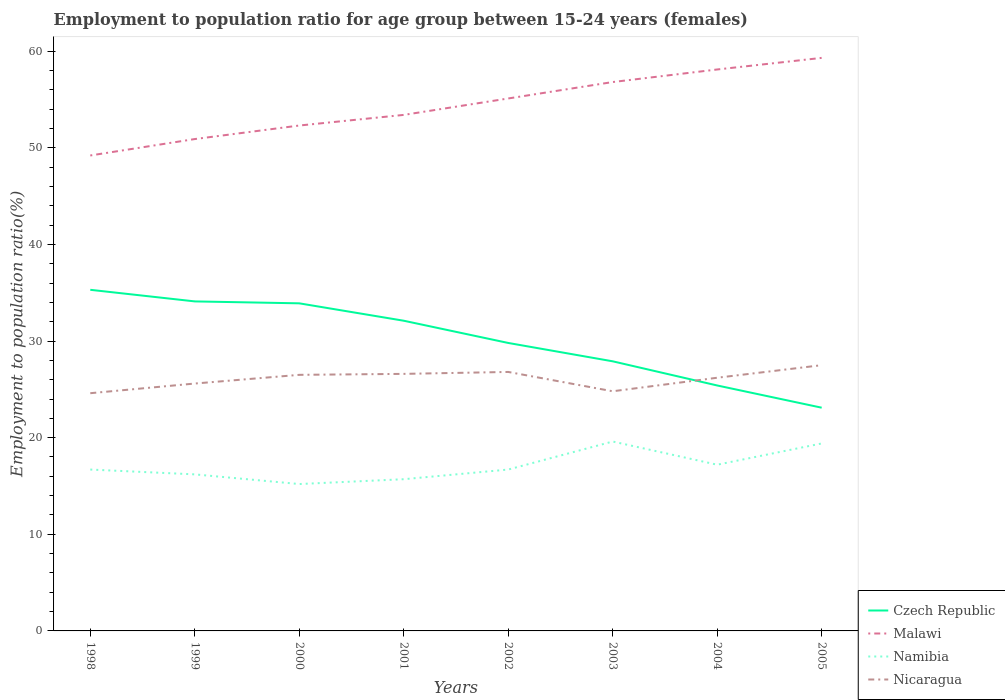How many different coloured lines are there?
Make the answer very short. 4. Does the line corresponding to Czech Republic intersect with the line corresponding to Nicaragua?
Offer a very short reply. Yes. Across all years, what is the maximum employment to population ratio in Nicaragua?
Offer a very short reply. 24.6. In which year was the employment to population ratio in Czech Republic maximum?
Your answer should be very brief. 2005. What is the total employment to population ratio in Malawi in the graph?
Provide a succinct answer. -8.4. What is the difference between the highest and the second highest employment to population ratio in Czech Republic?
Provide a succinct answer. 12.2. Are the values on the major ticks of Y-axis written in scientific E-notation?
Your answer should be compact. No. Does the graph contain grids?
Give a very brief answer. No. How are the legend labels stacked?
Provide a short and direct response. Vertical. What is the title of the graph?
Offer a terse response. Employment to population ratio for age group between 15-24 years (females). Does "Qatar" appear as one of the legend labels in the graph?
Keep it short and to the point. No. What is the label or title of the Y-axis?
Your response must be concise. Employment to population ratio(%). What is the Employment to population ratio(%) in Czech Republic in 1998?
Your response must be concise. 35.3. What is the Employment to population ratio(%) of Malawi in 1998?
Your answer should be compact. 49.2. What is the Employment to population ratio(%) in Namibia in 1998?
Offer a very short reply. 16.7. What is the Employment to population ratio(%) of Nicaragua in 1998?
Your answer should be compact. 24.6. What is the Employment to population ratio(%) of Czech Republic in 1999?
Your answer should be compact. 34.1. What is the Employment to population ratio(%) of Malawi in 1999?
Offer a very short reply. 50.9. What is the Employment to population ratio(%) of Namibia in 1999?
Your response must be concise. 16.2. What is the Employment to population ratio(%) of Nicaragua in 1999?
Your answer should be compact. 25.6. What is the Employment to population ratio(%) of Czech Republic in 2000?
Your response must be concise. 33.9. What is the Employment to population ratio(%) of Malawi in 2000?
Ensure brevity in your answer.  52.3. What is the Employment to population ratio(%) of Namibia in 2000?
Offer a very short reply. 15.2. What is the Employment to population ratio(%) in Nicaragua in 2000?
Ensure brevity in your answer.  26.5. What is the Employment to population ratio(%) of Czech Republic in 2001?
Offer a very short reply. 32.1. What is the Employment to population ratio(%) of Malawi in 2001?
Provide a succinct answer. 53.4. What is the Employment to population ratio(%) of Namibia in 2001?
Make the answer very short. 15.7. What is the Employment to population ratio(%) in Nicaragua in 2001?
Keep it short and to the point. 26.6. What is the Employment to population ratio(%) of Czech Republic in 2002?
Your response must be concise. 29.8. What is the Employment to population ratio(%) of Malawi in 2002?
Provide a succinct answer. 55.1. What is the Employment to population ratio(%) of Namibia in 2002?
Your answer should be very brief. 16.7. What is the Employment to population ratio(%) in Nicaragua in 2002?
Your answer should be very brief. 26.8. What is the Employment to population ratio(%) in Czech Republic in 2003?
Your answer should be compact. 27.9. What is the Employment to population ratio(%) of Malawi in 2003?
Make the answer very short. 56.8. What is the Employment to population ratio(%) of Namibia in 2003?
Your answer should be very brief. 19.6. What is the Employment to population ratio(%) in Nicaragua in 2003?
Ensure brevity in your answer.  24.8. What is the Employment to population ratio(%) in Czech Republic in 2004?
Offer a terse response. 25.4. What is the Employment to population ratio(%) in Malawi in 2004?
Your response must be concise. 58.1. What is the Employment to population ratio(%) in Namibia in 2004?
Ensure brevity in your answer.  17.2. What is the Employment to population ratio(%) in Nicaragua in 2004?
Provide a short and direct response. 26.2. What is the Employment to population ratio(%) of Czech Republic in 2005?
Offer a terse response. 23.1. What is the Employment to population ratio(%) in Malawi in 2005?
Offer a terse response. 59.3. What is the Employment to population ratio(%) of Namibia in 2005?
Keep it short and to the point. 19.4. Across all years, what is the maximum Employment to population ratio(%) in Czech Republic?
Ensure brevity in your answer.  35.3. Across all years, what is the maximum Employment to population ratio(%) of Malawi?
Provide a short and direct response. 59.3. Across all years, what is the maximum Employment to population ratio(%) in Namibia?
Provide a succinct answer. 19.6. Across all years, what is the maximum Employment to population ratio(%) of Nicaragua?
Provide a succinct answer. 27.5. Across all years, what is the minimum Employment to population ratio(%) of Czech Republic?
Your answer should be very brief. 23.1. Across all years, what is the minimum Employment to population ratio(%) in Malawi?
Your answer should be compact. 49.2. Across all years, what is the minimum Employment to population ratio(%) of Namibia?
Keep it short and to the point. 15.2. Across all years, what is the minimum Employment to population ratio(%) of Nicaragua?
Your response must be concise. 24.6. What is the total Employment to population ratio(%) in Czech Republic in the graph?
Keep it short and to the point. 241.6. What is the total Employment to population ratio(%) in Malawi in the graph?
Provide a succinct answer. 435.1. What is the total Employment to population ratio(%) in Namibia in the graph?
Your response must be concise. 136.7. What is the total Employment to population ratio(%) in Nicaragua in the graph?
Ensure brevity in your answer.  208.6. What is the difference between the Employment to population ratio(%) in Czech Republic in 1998 and that in 1999?
Keep it short and to the point. 1.2. What is the difference between the Employment to population ratio(%) in Malawi in 1998 and that in 1999?
Ensure brevity in your answer.  -1.7. What is the difference between the Employment to population ratio(%) of Malawi in 1998 and that in 2000?
Give a very brief answer. -3.1. What is the difference between the Employment to population ratio(%) in Namibia in 1998 and that in 2000?
Keep it short and to the point. 1.5. What is the difference between the Employment to population ratio(%) in Nicaragua in 1998 and that in 2000?
Your answer should be very brief. -1.9. What is the difference between the Employment to population ratio(%) in Malawi in 1998 and that in 2001?
Keep it short and to the point. -4.2. What is the difference between the Employment to population ratio(%) of Namibia in 1998 and that in 2001?
Ensure brevity in your answer.  1. What is the difference between the Employment to population ratio(%) in Czech Republic in 1998 and that in 2002?
Your answer should be compact. 5.5. What is the difference between the Employment to population ratio(%) in Namibia in 1998 and that in 2002?
Your answer should be very brief. 0. What is the difference between the Employment to population ratio(%) in Nicaragua in 1998 and that in 2002?
Ensure brevity in your answer.  -2.2. What is the difference between the Employment to population ratio(%) in Malawi in 1998 and that in 2003?
Your response must be concise. -7.6. What is the difference between the Employment to population ratio(%) of Namibia in 1998 and that in 2003?
Your response must be concise. -2.9. What is the difference between the Employment to population ratio(%) in Czech Republic in 1998 and that in 2004?
Make the answer very short. 9.9. What is the difference between the Employment to population ratio(%) in Malawi in 1998 and that in 2004?
Your answer should be compact. -8.9. What is the difference between the Employment to population ratio(%) of Namibia in 1998 and that in 2004?
Ensure brevity in your answer.  -0.5. What is the difference between the Employment to population ratio(%) in Namibia in 1998 and that in 2005?
Make the answer very short. -2.7. What is the difference between the Employment to population ratio(%) in Czech Republic in 1999 and that in 2000?
Provide a short and direct response. 0.2. What is the difference between the Employment to population ratio(%) of Namibia in 1999 and that in 2000?
Offer a terse response. 1. What is the difference between the Employment to population ratio(%) of Malawi in 1999 and that in 2001?
Make the answer very short. -2.5. What is the difference between the Employment to population ratio(%) in Namibia in 1999 and that in 2001?
Your answer should be very brief. 0.5. What is the difference between the Employment to population ratio(%) in Malawi in 1999 and that in 2002?
Your response must be concise. -4.2. What is the difference between the Employment to population ratio(%) of Namibia in 1999 and that in 2002?
Provide a succinct answer. -0.5. What is the difference between the Employment to population ratio(%) in Nicaragua in 1999 and that in 2002?
Ensure brevity in your answer.  -1.2. What is the difference between the Employment to population ratio(%) in Namibia in 1999 and that in 2003?
Ensure brevity in your answer.  -3.4. What is the difference between the Employment to population ratio(%) in Nicaragua in 1999 and that in 2003?
Provide a succinct answer. 0.8. What is the difference between the Employment to population ratio(%) in Malawi in 1999 and that in 2004?
Your response must be concise. -7.2. What is the difference between the Employment to population ratio(%) of Namibia in 1999 and that in 2004?
Provide a short and direct response. -1. What is the difference between the Employment to population ratio(%) of Nicaragua in 1999 and that in 2004?
Your response must be concise. -0.6. What is the difference between the Employment to population ratio(%) in Czech Republic in 1999 and that in 2005?
Offer a very short reply. 11. What is the difference between the Employment to population ratio(%) in Malawi in 1999 and that in 2005?
Ensure brevity in your answer.  -8.4. What is the difference between the Employment to population ratio(%) of Czech Republic in 2000 and that in 2001?
Ensure brevity in your answer.  1.8. What is the difference between the Employment to population ratio(%) in Nicaragua in 2000 and that in 2001?
Provide a succinct answer. -0.1. What is the difference between the Employment to population ratio(%) of Malawi in 2000 and that in 2002?
Provide a short and direct response. -2.8. What is the difference between the Employment to population ratio(%) of Nicaragua in 2000 and that in 2002?
Your answer should be compact. -0.3. What is the difference between the Employment to population ratio(%) in Namibia in 2000 and that in 2003?
Keep it short and to the point. -4.4. What is the difference between the Employment to population ratio(%) in Czech Republic in 2000 and that in 2004?
Ensure brevity in your answer.  8.5. What is the difference between the Employment to population ratio(%) in Namibia in 2000 and that in 2004?
Provide a short and direct response. -2. What is the difference between the Employment to population ratio(%) of Czech Republic in 2000 and that in 2005?
Keep it short and to the point. 10.8. What is the difference between the Employment to population ratio(%) of Malawi in 2000 and that in 2005?
Offer a terse response. -7. What is the difference between the Employment to population ratio(%) in Namibia in 2000 and that in 2005?
Your answer should be compact. -4.2. What is the difference between the Employment to population ratio(%) of Nicaragua in 2000 and that in 2005?
Make the answer very short. -1. What is the difference between the Employment to population ratio(%) of Namibia in 2001 and that in 2002?
Offer a terse response. -1. What is the difference between the Employment to population ratio(%) of Czech Republic in 2001 and that in 2003?
Provide a succinct answer. 4.2. What is the difference between the Employment to population ratio(%) in Malawi in 2001 and that in 2003?
Keep it short and to the point. -3.4. What is the difference between the Employment to population ratio(%) in Nicaragua in 2001 and that in 2003?
Your answer should be compact. 1.8. What is the difference between the Employment to population ratio(%) of Nicaragua in 2001 and that in 2004?
Offer a very short reply. 0.4. What is the difference between the Employment to population ratio(%) of Malawi in 2001 and that in 2005?
Your answer should be very brief. -5.9. What is the difference between the Employment to population ratio(%) in Nicaragua in 2001 and that in 2005?
Give a very brief answer. -0.9. What is the difference between the Employment to population ratio(%) of Malawi in 2002 and that in 2003?
Give a very brief answer. -1.7. What is the difference between the Employment to population ratio(%) in Namibia in 2002 and that in 2003?
Your answer should be compact. -2.9. What is the difference between the Employment to population ratio(%) of Nicaragua in 2002 and that in 2003?
Offer a very short reply. 2. What is the difference between the Employment to population ratio(%) of Czech Republic in 2002 and that in 2004?
Offer a very short reply. 4.4. What is the difference between the Employment to population ratio(%) of Malawi in 2002 and that in 2004?
Keep it short and to the point. -3. What is the difference between the Employment to population ratio(%) of Nicaragua in 2002 and that in 2004?
Your answer should be compact. 0.6. What is the difference between the Employment to population ratio(%) in Czech Republic in 2002 and that in 2005?
Give a very brief answer. 6.7. What is the difference between the Employment to population ratio(%) in Malawi in 2002 and that in 2005?
Your response must be concise. -4.2. What is the difference between the Employment to population ratio(%) of Namibia in 2002 and that in 2005?
Offer a terse response. -2.7. What is the difference between the Employment to population ratio(%) in Czech Republic in 2003 and that in 2004?
Your answer should be compact. 2.5. What is the difference between the Employment to population ratio(%) of Malawi in 2003 and that in 2004?
Offer a very short reply. -1.3. What is the difference between the Employment to population ratio(%) of Nicaragua in 2003 and that in 2004?
Ensure brevity in your answer.  -1.4. What is the difference between the Employment to population ratio(%) of Czech Republic in 2003 and that in 2005?
Provide a succinct answer. 4.8. What is the difference between the Employment to population ratio(%) of Malawi in 2003 and that in 2005?
Keep it short and to the point. -2.5. What is the difference between the Employment to population ratio(%) of Czech Republic in 2004 and that in 2005?
Make the answer very short. 2.3. What is the difference between the Employment to population ratio(%) of Malawi in 2004 and that in 2005?
Make the answer very short. -1.2. What is the difference between the Employment to population ratio(%) of Namibia in 2004 and that in 2005?
Give a very brief answer. -2.2. What is the difference between the Employment to population ratio(%) of Czech Republic in 1998 and the Employment to population ratio(%) of Malawi in 1999?
Your answer should be compact. -15.6. What is the difference between the Employment to population ratio(%) in Malawi in 1998 and the Employment to population ratio(%) in Nicaragua in 1999?
Make the answer very short. 23.6. What is the difference between the Employment to population ratio(%) of Namibia in 1998 and the Employment to population ratio(%) of Nicaragua in 1999?
Your response must be concise. -8.9. What is the difference between the Employment to population ratio(%) in Czech Republic in 1998 and the Employment to population ratio(%) in Malawi in 2000?
Make the answer very short. -17. What is the difference between the Employment to population ratio(%) of Czech Republic in 1998 and the Employment to population ratio(%) of Namibia in 2000?
Keep it short and to the point. 20.1. What is the difference between the Employment to population ratio(%) of Malawi in 1998 and the Employment to population ratio(%) of Nicaragua in 2000?
Your response must be concise. 22.7. What is the difference between the Employment to population ratio(%) of Namibia in 1998 and the Employment to population ratio(%) of Nicaragua in 2000?
Give a very brief answer. -9.8. What is the difference between the Employment to population ratio(%) in Czech Republic in 1998 and the Employment to population ratio(%) in Malawi in 2001?
Ensure brevity in your answer.  -18.1. What is the difference between the Employment to population ratio(%) of Czech Republic in 1998 and the Employment to population ratio(%) of Namibia in 2001?
Provide a short and direct response. 19.6. What is the difference between the Employment to population ratio(%) of Czech Republic in 1998 and the Employment to population ratio(%) of Nicaragua in 2001?
Give a very brief answer. 8.7. What is the difference between the Employment to population ratio(%) of Malawi in 1998 and the Employment to population ratio(%) of Namibia in 2001?
Give a very brief answer. 33.5. What is the difference between the Employment to population ratio(%) of Malawi in 1998 and the Employment to population ratio(%) of Nicaragua in 2001?
Keep it short and to the point. 22.6. What is the difference between the Employment to population ratio(%) in Namibia in 1998 and the Employment to population ratio(%) in Nicaragua in 2001?
Keep it short and to the point. -9.9. What is the difference between the Employment to population ratio(%) of Czech Republic in 1998 and the Employment to population ratio(%) of Malawi in 2002?
Offer a terse response. -19.8. What is the difference between the Employment to population ratio(%) in Malawi in 1998 and the Employment to population ratio(%) in Namibia in 2002?
Provide a short and direct response. 32.5. What is the difference between the Employment to population ratio(%) of Malawi in 1998 and the Employment to population ratio(%) of Nicaragua in 2002?
Make the answer very short. 22.4. What is the difference between the Employment to population ratio(%) in Namibia in 1998 and the Employment to population ratio(%) in Nicaragua in 2002?
Your answer should be compact. -10.1. What is the difference between the Employment to population ratio(%) of Czech Republic in 1998 and the Employment to population ratio(%) of Malawi in 2003?
Your response must be concise. -21.5. What is the difference between the Employment to population ratio(%) of Malawi in 1998 and the Employment to population ratio(%) of Namibia in 2003?
Provide a succinct answer. 29.6. What is the difference between the Employment to population ratio(%) of Malawi in 1998 and the Employment to population ratio(%) of Nicaragua in 2003?
Make the answer very short. 24.4. What is the difference between the Employment to population ratio(%) of Czech Republic in 1998 and the Employment to population ratio(%) of Malawi in 2004?
Make the answer very short. -22.8. What is the difference between the Employment to population ratio(%) in Czech Republic in 1998 and the Employment to population ratio(%) in Namibia in 2004?
Keep it short and to the point. 18.1. What is the difference between the Employment to population ratio(%) of Czech Republic in 1998 and the Employment to population ratio(%) of Nicaragua in 2004?
Your answer should be very brief. 9.1. What is the difference between the Employment to population ratio(%) in Czech Republic in 1998 and the Employment to population ratio(%) in Malawi in 2005?
Give a very brief answer. -24. What is the difference between the Employment to population ratio(%) in Czech Republic in 1998 and the Employment to population ratio(%) in Namibia in 2005?
Provide a succinct answer. 15.9. What is the difference between the Employment to population ratio(%) in Czech Republic in 1998 and the Employment to population ratio(%) in Nicaragua in 2005?
Provide a short and direct response. 7.8. What is the difference between the Employment to population ratio(%) in Malawi in 1998 and the Employment to population ratio(%) in Namibia in 2005?
Make the answer very short. 29.8. What is the difference between the Employment to population ratio(%) of Malawi in 1998 and the Employment to population ratio(%) of Nicaragua in 2005?
Your answer should be compact. 21.7. What is the difference between the Employment to population ratio(%) in Namibia in 1998 and the Employment to population ratio(%) in Nicaragua in 2005?
Your answer should be very brief. -10.8. What is the difference between the Employment to population ratio(%) of Czech Republic in 1999 and the Employment to population ratio(%) of Malawi in 2000?
Ensure brevity in your answer.  -18.2. What is the difference between the Employment to population ratio(%) of Czech Republic in 1999 and the Employment to population ratio(%) of Namibia in 2000?
Offer a very short reply. 18.9. What is the difference between the Employment to population ratio(%) in Czech Republic in 1999 and the Employment to population ratio(%) in Nicaragua in 2000?
Ensure brevity in your answer.  7.6. What is the difference between the Employment to population ratio(%) of Malawi in 1999 and the Employment to population ratio(%) of Namibia in 2000?
Keep it short and to the point. 35.7. What is the difference between the Employment to population ratio(%) of Malawi in 1999 and the Employment to population ratio(%) of Nicaragua in 2000?
Make the answer very short. 24.4. What is the difference between the Employment to population ratio(%) in Namibia in 1999 and the Employment to population ratio(%) in Nicaragua in 2000?
Your answer should be very brief. -10.3. What is the difference between the Employment to population ratio(%) of Czech Republic in 1999 and the Employment to population ratio(%) of Malawi in 2001?
Make the answer very short. -19.3. What is the difference between the Employment to population ratio(%) in Czech Republic in 1999 and the Employment to population ratio(%) in Nicaragua in 2001?
Make the answer very short. 7.5. What is the difference between the Employment to population ratio(%) in Malawi in 1999 and the Employment to population ratio(%) in Namibia in 2001?
Provide a succinct answer. 35.2. What is the difference between the Employment to population ratio(%) of Malawi in 1999 and the Employment to population ratio(%) of Nicaragua in 2001?
Provide a short and direct response. 24.3. What is the difference between the Employment to population ratio(%) of Namibia in 1999 and the Employment to population ratio(%) of Nicaragua in 2001?
Ensure brevity in your answer.  -10.4. What is the difference between the Employment to population ratio(%) of Czech Republic in 1999 and the Employment to population ratio(%) of Malawi in 2002?
Make the answer very short. -21. What is the difference between the Employment to population ratio(%) in Czech Republic in 1999 and the Employment to population ratio(%) in Nicaragua in 2002?
Ensure brevity in your answer.  7.3. What is the difference between the Employment to population ratio(%) of Malawi in 1999 and the Employment to population ratio(%) of Namibia in 2002?
Offer a terse response. 34.2. What is the difference between the Employment to population ratio(%) in Malawi in 1999 and the Employment to population ratio(%) in Nicaragua in 2002?
Offer a terse response. 24.1. What is the difference between the Employment to population ratio(%) in Namibia in 1999 and the Employment to population ratio(%) in Nicaragua in 2002?
Give a very brief answer. -10.6. What is the difference between the Employment to population ratio(%) in Czech Republic in 1999 and the Employment to population ratio(%) in Malawi in 2003?
Offer a very short reply. -22.7. What is the difference between the Employment to population ratio(%) of Czech Republic in 1999 and the Employment to population ratio(%) of Nicaragua in 2003?
Provide a short and direct response. 9.3. What is the difference between the Employment to population ratio(%) in Malawi in 1999 and the Employment to population ratio(%) in Namibia in 2003?
Provide a short and direct response. 31.3. What is the difference between the Employment to population ratio(%) in Malawi in 1999 and the Employment to population ratio(%) in Nicaragua in 2003?
Make the answer very short. 26.1. What is the difference between the Employment to population ratio(%) in Namibia in 1999 and the Employment to population ratio(%) in Nicaragua in 2003?
Give a very brief answer. -8.6. What is the difference between the Employment to population ratio(%) in Czech Republic in 1999 and the Employment to population ratio(%) in Malawi in 2004?
Offer a very short reply. -24. What is the difference between the Employment to population ratio(%) of Czech Republic in 1999 and the Employment to population ratio(%) of Namibia in 2004?
Offer a very short reply. 16.9. What is the difference between the Employment to population ratio(%) in Czech Republic in 1999 and the Employment to population ratio(%) in Nicaragua in 2004?
Provide a short and direct response. 7.9. What is the difference between the Employment to population ratio(%) of Malawi in 1999 and the Employment to population ratio(%) of Namibia in 2004?
Provide a short and direct response. 33.7. What is the difference between the Employment to population ratio(%) in Malawi in 1999 and the Employment to population ratio(%) in Nicaragua in 2004?
Your response must be concise. 24.7. What is the difference between the Employment to population ratio(%) in Czech Republic in 1999 and the Employment to population ratio(%) in Malawi in 2005?
Offer a terse response. -25.2. What is the difference between the Employment to population ratio(%) in Czech Republic in 1999 and the Employment to population ratio(%) in Namibia in 2005?
Offer a terse response. 14.7. What is the difference between the Employment to population ratio(%) in Czech Republic in 1999 and the Employment to population ratio(%) in Nicaragua in 2005?
Give a very brief answer. 6.6. What is the difference between the Employment to population ratio(%) of Malawi in 1999 and the Employment to population ratio(%) of Namibia in 2005?
Your answer should be compact. 31.5. What is the difference between the Employment to population ratio(%) of Malawi in 1999 and the Employment to population ratio(%) of Nicaragua in 2005?
Provide a short and direct response. 23.4. What is the difference between the Employment to population ratio(%) in Czech Republic in 2000 and the Employment to population ratio(%) in Malawi in 2001?
Offer a terse response. -19.5. What is the difference between the Employment to population ratio(%) in Malawi in 2000 and the Employment to population ratio(%) in Namibia in 2001?
Make the answer very short. 36.6. What is the difference between the Employment to population ratio(%) in Malawi in 2000 and the Employment to population ratio(%) in Nicaragua in 2001?
Your response must be concise. 25.7. What is the difference between the Employment to population ratio(%) of Namibia in 2000 and the Employment to population ratio(%) of Nicaragua in 2001?
Offer a very short reply. -11.4. What is the difference between the Employment to population ratio(%) in Czech Republic in 2000 and the Employment to population ratio(%) in Malawi in 2002?
Provide a short and direct response. -21.2. What is the difference between the Employment to population ratio(%) of Czech Republic in 2000 and the Employment to population ratio(%) of Namibia in 2002?
Your answer should be very brief. 17.2. What is the difference between the Employment to population ratio(%) in Malawi in 2000 and the Employment to population ratio(%) in Namibia in 2002?
Offer a terse response. 35.6. What is the difference between the Employment to population ratio(%) of Malawi in 2000 and the Employment to population ratio(%) of Nicaragua in 2002?
Provide a short and direct response. 25.5. What is the difference between the Employment to population ratio(%) of Namibia in 2000 and the Employment to population ratio(%) of Nicaragua in 2002?
Your answer should be compact. -11.6. What is the difference between the Employment to population ratio(%) of Czech Republic in 2000 and the Employment to population ratio(%) of Malawi in 2003?
Your response must be concise. -22.9. What is the difference between the Employment to population ratio(%) in Czech Republic in 2000 and the Employment to population ratio(%) in Namibia in 2003?
Make the answer very short. 14.3. What is the difference between the Employment to population ratio(%) in Malawi in 2000 and the Employment to population ratio(%) in Namibia in 2003?
Offer a very short reply. 32.7. What is the difference between the Employment to population ratio(%) of Czech Republic in 2000 and the Employment to population ratio(%) of Malawi in 2004?
Keep it short and to the point. -24.2. What is the difference between the Employment to population ratio(%) of Czech Republic in 2000 and the Employment to population ratio(%) of Namibia in 2004?
Make the answer very short. 16.7. What is the difference between the Employment to population ratio(%) in Malawi in 2000 and the Employment to population ratio(%) in Namibia in 2004?
Offer a terse response. 35.1. What is the difference between the Employment to population ratio(%) in Malawi in 2000 and the Employment to population ratio(%) in Nicaragua in 2004?
Your answer should be compact. 26.1. What is the difference between the Employment to population ratio(%) in Namibia in 2000 and the Employment to population ratio(%) in Nicaragua in 2004?
Your answer should be very brief. -11. What is the difference between the Employment to population ratio(%) in Czech Republic in 2000 and the Employment to population ratio(%) in Malawi in 2005?
Your answer should be very brief. -25.4. What is the difference between the Employment to population ratio(%) in Malawi in 2000 and the Employment to population ratio(%) in Namibia in 2005?
Keep it short and to the point. 32.9. What is the difference between the Employment to population ratio(%) of Malawi in 2000 and the Employment to population ratio(%) of Nicaragua in 2005?
Make the answer very short. 24.8. What is the difference between the Employment to population ratio(%) of Namibia in 2000 and the Employment to population ratio(%) of Nicaragua in 2005?
Keep it short and to the point. -12.3. What is the difference between the Employment to population ratio(%) in Czech Republic in 2001 and the Employment to population ratio(%) in Malawi in 2002?
Your answer should be compact. -23. What is the difference between the Employment to population ratio(%) of Malawi in 2001 and the Employment to population ratio(%) of Namibia in 2002?
Offer a very short reply. 36.7. What is the difference between the Employment to population ratio(%) in Malawi in 2001 and the Employment to population ratio(%) in Nicaragua in 2002?
Offer a very short reply. 26.6. What is the difference between the Employment to population ratio(%) in Namibia in 2001 and the Employment to population ratio(%) in Nicaragua in 2002?
Offer a very short reply. -11.1. What is the difference between the Employment to population ratio(%) of Czech Republic in 2001 and the Employment to population ratio(%) of Malawi in 2003?
Keep it short and to the point. -24.7. What is the difference between the Employment to population ratio(%) in Czech Republic in 2001 and the Employment to population ratio(%) in Namibia in 2003?
Ensure brevity in your answer.  12.5. What is the difference between the Employment to population ratio(%) in Malawi in 2001 and the Employment to population ratio(%) in Namibia in 2003?
Give a very brief answer. 33.8. What is the difference between the Employment to population ratio(%) in Malawi in 2001 and the Employment to population ratio(%) in Nicaragua in 2003?
Provide a succinct answer. 28.6. What is the difference between the Employment to population ratio(%) in Namibia in 2001 and the Employment to population ratio(%) in Nicaragua in 2003?
Offer a terse response. -9.1. What is the difference between the Employment to population ratio(%) in Czech Republic in 2001 and the Employment to population ratio(%) in Malawi in 2004?
Your response must be concise. -26. What is the difference between the Employment to population ratio(%) of Malawi in 2001 and the Employment to population ratio(%) of Namibia in 2004?
Offer a very short reply. 36.2. What is the difference between the Employment to population ratio(%) in Malawi in 2001 and the Employment to population ratio(%) in Nicaragua in 2004?
Offer a very short reply. 27.2. What is the difference between the Employment to population ratio(%) of Czech Republic in 2001 and the Employment to population ratio(%) of Malawi in 2005?
Your answer should be very brief. -27.2. What is the difference between the Employment to population ratio(%) of Malawi in 2001 and the Employment to population ratio(%) of Nicaragua in 2005?
Offer a terse response. 25.9. What is the difference between the Employment to population ratio(%) of Namibia in 2001 and the Employment to population ratio(%) of Nicaragua in 2005?
Keep it short and to the point. -11.8. What is the difference between the Employment to population ratio(%) of Czech Republic in 2002 and the Employment to population ratio(%) of Namibia in 2003?
Ensure brevity in your answer.  10.2. What is the difference between the Employment to population ratio(%) in Malawi in 2002 and the Employment to population ratio(%) in Namibia in 2003?
Your answer should be very brief. 35.5. What is the difference between the Employment to population ratio(%) in Malawi in 2002 and the Employment to population ratio(%) in Nicaragua in 2003?
Provide a short and direct response. 30.3. What is the difference between the Employment to population ratio(%) in Namibia in 2002 and the Employment to population ratio(%) in Nicaragua in 2003?
Your answer should be compact. -8.1. What is the difference between the Employment to population ratio(%) in Czech Republic in 2002 and the Employment to population ratio(%) in Malawi in 2004?
Give a very brief answer. -28.3. What is the difference between the Employment to population ratio(%) in Czech Republic in 2002 and the Employment to population ratio(%) in Nicaragua in 2004?
Ensure brevity in your answer.  3.6. What is the difference between the Employment to population ratio(%) of Malawi in 2002 and the Employment to population ratio(%) of Namibia in 2004?
Provide a short and direct response. 37.9. What is the difference between the Employment to population ratio(%) in Malawi in 2002 and the Employment to population ratio(%) in Nicaragua in 2004?
Your response must be concise. 28.9. What is the difference between the Employment to population ratio(%) of Czech Republic in 2002 and the Employment to population ratio(%) of Malawi in 2005?
Keep it short and to the point. -29.5. What is the difference between the Employment to population ratio(%) in Czech Republic in 2002 and the Employment to population ratio(%) in Namibia in 2005?
Offer a terse response. 10.4. What is the difference between the Employment to population ratio(%) in Malawi in 2002 and the Employment to population ratio(%) in Namibia in 2005?
Provide a succinct answer. 35.7. What is the difference between the Employment to population ratio(%) in Malawi in 2002 and the Employment to population ratio(%) in Nicaragua in 2005?
Offer a terse response. 27.6. What is the difference between the Employment to population ratio(%) in Namibia in 2002 and the Employment to population ratio(%) in Nicaragua in 2005?
Your answer should be very brief. -10.8. What is the difference between the Employment to population ratio(%) of Czech Republic in 2003 and the Employment to population ratio(%) of Malawi in 2004?
Your answer should be compact. -30.2. What is the difference between the Employment to population ratio(%) in Czech Republic in 2003 and the Employment to population ratio(%) in Namibia in 2004?
Give a very brief answer. 10.7. What is the difference between the Employment to population ratio(%) in Czech Republic in 2003 and the Employment to population ratio(%) in Nicaragua in 2004?
Offer a very short reply. 1.7. What is the difference between the Employment to population ratio(%) of Malawi in 2003 and the Employment to population ratio(%) of Namibia in 2004?
Your response must be concise. 39.6. What is the difference between the Employment to population ratio(%) of Malawi in 2003 and the Employment to population ratio(%) of Nicaragua in 2004?
Keep it short and to the point. 30.6. What is the difference between the Employment to population ratio(%) of Namibia in 2003 and the Employment to population ratio(%) of Nicaragua in 2004?
Make the answer very short. -6.6. What is the difference between the Employment to population ratio(%) in Czech Republic in 2003 and the Employment to population ratio(%) in Malawi in 2005?
Offer a very short reply. -31.4. What is the difference between the Employment to population ratio(%) of Czech Republic in 2003 and the Employment to population ratio(%) of Namibia in 2005?
Your answer should be very brief. 8.5. What is the difference between the Employment to population ratio(%) of Czech Republic in 2003 and the Employment to population ratio(%) of Nicaragua in 2005?
Offer a terse response. 0.4. What is the difference between the Employment to population ratio(%) in Malawi in 2003 and the Employment to population ratio(%) in Namibia in 2005?
Provide a succinct answer. 37.4. What is the difference between the Employment to population ratio(%) in Malawi in 2003 and the Employment to population ratio(%) in Nicaragua in 2005?
Offer a terse response. 29.3. What is the difference between the Employment to population ratio(%) of Namibia in 2003 and the Employment to population ratio(%) of Nicaragua in 2005?
Ensure brevity in your answer.  -7.9. What is the difference between the Employment to population ratio(%) in Czech Republic in 2004 and the Employment to population ratio(%) in Malawi in 2005?
Provide a succinct answer. -33.9. What is the difference between the Employment to population ratio(%) of Czech Republic in 2004 and the Employment to population ratio(%) of Namibia in 2005?
Give a very brief answer. 6. What is the difference between the Employment to population ratio(%) of Malawi in 2004 and the Employment to population ratio(%) of Namibia in 2005?
Give a very brief answer. 38.7. What is the difference between the Employment to population ratio(%) of Malawi in 2004 and the Employment to population ratio(%) of Nicaragua in 2005?
Offer a very short reply. 30.6. What is the average Employment to population ratio(%) in Czech Republic per year?
Keep it short and to the point. 30.2. What is the average Employment to population ratio(%) of Malawi per year?
Keep it short and to the point. 54.39. What is the average Employment to population ratio(%) in Namibia per year?
Offer a very short reply. 17.09. What is the average Employment to population ratio(%) in Nicaragua per year?
Offer a very short reply. 26.07. In the year 1998, what is the difference between the Employment to population ratio(%) in Czech Republic and Employment to population ratio(%) in Namibia?
Ensure brevity in your answer.  18.6. In the year 1998, what is the difference between the Employment to population ratio(%) in Malawi and Employment to population ratio(%) in Namibia?
Offer a terse response. 32.5. In the year 1998, what is the difference between the Employment to population ratio(%) of Malawi and Employment to population ratio(%) of Nicaragua?
Offer a very short reply. 24.6. In the year 1999, what is the difference between the Employment to population ratio(%) of Czech Republic and Employment to population ratio(%) of Malawi?
Provide a succinct answer. -16.8. In the year 1999, what is the difference between the Employment to population ratio(%) of Malawi and Employment to population ratio(%) of Namibia?
Keep it short and to the point. 34.7. In the year 1999, what is the difference between the Employment to population ratio(%) in Malawi and Employment to population ratio(%) in Nicaragua?
Your answer should be compact. 25.3. In the year 2000, what is the difference between the Employment to population ratio(%) of Czech Republic and Employment to population ratio(%) of Malawi?
Offer a very short reply. -18.4. In the year 2000, what is the difference between the Employment to population ratio(%) in Czech Republic and Employment to population ratio(%) in Namibia?
Give a very brief answer. 18.7. In the year 2000, what is the difference between the Employment to population ratio(%) in Malawi and Employment to population ratio(%) in Namibia?
Your answer should be very brief. 37.1. In the year 2000, what is the difference between the Employment to population ratio(%) in Malawi and Employment to population ratio(%) in Nicaragua?
Keep it short and to the point. 25.8. In the year 2000, what is the difference between the Employment to population ratio(%) in Namibia and Employment to population ratio(%) in Nicaragua?
Offer a terse response. -11.3. In the year 2001, what is the difference between the Employment to population ratio(%) of Czech Republic and Employment to population ratio(%) of Malawi?
Your response must be concise. -21.3. In the year 2001, what is the difference between the Employment to population ratio(%) in Czech Republic and Employment to population ratio(%) in Namibia?
Provide a succinct answer. 16.4. In the year 2001, what is the difference between the Employment to population ratio(%) in Czech Republic and Employment to population ratio(%) in Nicaragua?
Make the answer very short. 5.5. In the year 2001, what is the difference between the Employment to population ratio(%) in Malawi and Employment to population ratio(%) in Namibia?
Your answer should be compact. 37.7. In the year 2001, what is the difference between the Employment to population ratio(%) in Malawi and Employment to population ratio(%) in Nicaragua?
Your answer should be compact. 26.8. In the year 2001, what is the difference between the Employment to population ratio(%) of Namibia and Employment to population ratio(%) of Nicaragua?
Your answer should be compact. -10.9. In the year 2002, what is the difference between the Employment to population ratio(%) of Czech Republic and Employment to population ratio(%) of Malawi?
Your answer should be compact. -25.3. In the year 2002, what is the difference between the Employment to population ratio(%) in Czech Republic and Employment to population ratio(%) in Namibia?
Make the answer very short. 13.1. In the year 2002, what is the difference between the Employment to population ratio(%) of Malawi and Employment to population ratio(%) of Namibia?
Provide a short and direct response. 38.4. In the year 2002, what is the difference between the Employment to population ratio(%) of Malawi and Employment to population ratio(%) of Nicaragua?
Offer a very short reply. 28.3. In the year 2003, what is the difference between the Employment to population ratio(%) of Czech Republic and Employment to population ratio(%) of Malawi?
Provide a short and direct response. -28.9. In the year 2003, what is the difference between the Employment to population ratio(%) in Czech Republic and Employment to population ratio(%) in Namibia?
Keep it short and to the point. 8.3. In the year 2003, what is the difference between the Employment to population ratio(%) of Malawi and Employment to population ratio(%) of Namibia?
Offer a very short reply. 37.2. In the year 2003, what is the difference between the Employment to population ratio(%) of Malawi and Employment to population ratio(%) of Nicaragua?
Ensure brevity in your answer.  32. In the year 2004, what is the difference between the Employment to population ratio(%) in Czech Republic and Employment to population ratio(%) in Malawi?
Make the answer very short. -32.7. In the year 2004, what is the difference between the Employment to population ratio(%) in Czech Republic and Employment to population ratio(%) in Nicaragua?
Keep it short and to the point. -0.8. In the year 2004, what is the difference between the Employment to population ratio(%) of Malawi and Employment to population ratio(%) of Namibia?
Provide a short and direct response. 40.9. In the year 2004, what is the difference between the Employment to population ratio(%) in Malawi and Employment to population ratio(%) in Nicaragua?
Give a very brief answer. 31.9. In the year 2004, what is the difference between the Employment to population ratio(%) in Namibia and Employment to population ratio(%) in Nicaragua?
Offer a terse response. -9. In the year 2005, what is the difference between the Employment to population ratio(%) in Czech Republic and Employment to population ratio(%) in Malawi?
Your answer should be compact. -36.2. In the year 2005, what is the difference between the Employment to population ratio(%) in Czech Republic and Employment to population ratio(%) in Nicaragua?
Your answer should be very brief. -4.4. In the year 2005, what is the difference between the Employment to population ratio(%) of Malawi and Employment to population ratio(%) of Namibia?
Provide a short and direct response. 39.9. In the year 2005, what is the difference between the Employment to population ratio(%) of Malawi and Employment to population ratio(%) of Nicaragua?
Provide a succinct answer. 31.8. What is the ratio of the Employment to population ratio(%) of Czech Republic in 1998 to that in 1999?
Your answer should be compact. 1.04. What is the ratio of the Employment to population ratio(%) of Malawi in 1998 to that in 1999?
Provide a short and direct response. 0.97. What is the ratio of the Employment to population ratio(%) of Namibia in 1998 to that in 1999?
Offer a terse response. 1.03. What is the ratio of the Employment to population ratio(%) in Nicaragua in 1998 to that in 1999?
Offer a very short reply. 0.96. What is the ratio of the Employment to population ratio(%) of Czech Republic in 1998 to that in 2000?
Your response must be concise. 1.04. What is the ratio of the Employment to population ratio(%) of Malawi in 1998 to that in 2000?
Offer a terse response. 0.94. What is the ratio of the Employment to population ratio(%) in Namibia in 1998 to that in 2000?
Your response must be concise. 1.1. What is the ratio of the Employment to population ratio(%) of Nicaragua in 1998 to that in 2000?
Provide a short and direct response. 0.93. What is the ratio of the Employment to population ratio(%) of Czech Republic in 1998 to that in 2001?
Offer a terse response. 1.1. What is the ratio of the Employment to population ratio(%) in Malawi in 1998 to that in 2001?
Offer a terse response. 0.92. What is the ratio of the Employment to population ratio(%) of Namibia in 1998 to that in 2001?
Make the answer very short. 1.06. What is the ratio of the Employment to population ratio(%) in Nicaragua in 1998 to that in 2001?
Make the answer very short. 0.92. What is the ratio of the Employment to population ratio(%) in Czech Republic in 1998 to that in 2002?
Offer a very short reply. 1.18. What is the ratio of the Employment to population ratio(%) in Malawi in 1998 to that in 2002?
Provide a succinct answer. 0.89. What is the ratio of the Employment to population ratio(%) in Namibia in 1998 to that in 2002?
Your response must be concise. 1. What is the ratio of the Employment to population ratio(%) of Nicaragua in 1998 to that in 2002?
Give a very brief answer. 0.92. What is the ratio of the Employment to population ratio(%) of Czech Republic in 1998 to that in 2003?
Offer a very short reply. 1.27. What is the ratio of the Employment to population ratio(%) of Malawi in 1998 to that in 2003?
Your answer should be very brief. 0.87. What is the ratio of the Employment to population ratio(%) in Namibia in 1998 to that in 2003?
Give a very brief answer. 0.85. What is the ratio of the Employment to population ratio(%) in Czech Republic in 1998 to that in 2004?
Provide a short and direct response. 1.39. What is the ratio of the Employment to population ratio(%) of Malawi in 1998 to that in 2004?
Keep it short and to the point. 0.85. What is the ratio of the Employment to population ratio(%) in Namibia in 1998 to that in 2004?
Offer a terse response. 0.97. What is the ratio of the Employment to population ratio(%) in Nicaragua in 1998 to that in 2004?
Make the answer very short. 0.94. What is the ratio of the Employment to population ratio(%) of Czech Republic in 1998 to that in 2005?
Provide a short and direct response. 1.53. What is the ratio of the Employment to population ratio(%) in Malawi in 1998 to that in 2005?
Your response must be concise. 0.83. What is the ratio of the Employment to population ratio(%) in Namibia in 1998 to that in 2005?
Ensure brevity in your answer.  0.86. What is the ratio of the Employment to population ratio(%) in Nicaragua in 1998 to that in 2005?
Your answer should be compact. 0.89. What is the ratio of the Employment to population ratio(%) of Czech Republic in 1999 to that in 2000?
Give a very brief answer. 1.01. What is the ratio of the Employment to population ratio(%) of Malawi in 1999 to that in 2000?
Your answer should be compact. 0.97. What is the ratio of the Employment to population ratio(%) of Namibia in 1999 to that in 2000?
Provide a succinct answer. 1.07. What is the ratio of the Employment to population ratio(%) of Nicaragua in 1999 to that in 2000?
Your answer should be very brief. 0.97. What is the ratio of the Employment to population ratio(%) of Czech Republic in 1999 to that in 2001?
Keep it short and to the point. 1.06. What is the ratio of the Employment to population ratio(%) in Malawi in 1999 to that in 2001?
Provide a succinct answer. 0.95. What is the ratio of the Employment to population ratio(%) of Namibia in 1999 to that in 2001?
Give a very brief answer. 1.03. What is the ratio of the Employment to population ratio(%) in Nicaragua in 1999 to that in 2001?
Your response must be concise. 0.96. What is the ratio of the Employment to population ratio(%) in Czech Republic in 1999 to that in 2002?
Give a very brief answer. 1.14. What is the ratio of the Employment to population ratio(%) in Malawi in 1999 to that in 2002?
Give a very brief answer. 0.92. What is the ratio of the Employment to population ratio(%) of Namibia in 1999 to that in 2002?
Your response must be concise. 0.97. What is the ratio of the Employment to population ratio(%) in Nicaragua in 1999 to that in 2002?
Offer a terse response. 0.96. What is the ratio of the Employment to population ratio(%) in Czech Republic in 1999 to that in 2003?
Your answer should be very brief. 1.22. What is the ratio of the Employment to population ratio(%) of Malawi in 1999 to that in 2003?
Your response must be concise. 0.9. What is the ratio of the Employment to population ratio(%) of Namibia in 1999 to that in 2003?
Keep it short and to the point. 0.83. What is the ratio of the Employment to population ratio(%) in Nicaragua in 1999 to that in 2003?
Ensure brevity in your answer.  1.03. What is the ratio of the Employment to population ratio(%) of Czech Republic in 1999 to that in 2004?
Your answer should be compact. 1.34. What is the ratio of the Employment to population ratio(%) of Malawi in 1999 to that in 2004?
Offer a terse response. 0.88. What is the ratio of the Employment to population ratio(%) in Namibia in 1999 to that in 2004?
Offer a very short reply. 0.94. What is the ratio of the Employment to population ratio(%) of Nicaragua in 1999 to that in 2004?
Keep it short and to the point. 0.98. What is the ratio of the Employment to population ratio(%) of Czech Republic in 1999 to that in 2005?
Keep it short and to the point. 1.48. What is the ratio of the Employment to population ratio(%) in Malawi in 1999 to that in 2005?
Your response must be concise. 0.86. What is the ratio of the Employment to population ratio(%) of Namibia in 1999 to that in 2005?
Give a very brief answer. 0.84. What is the ratio of the Employment to population ratio(%) in Nicaragua in 1999 to that in 2005?
Your response must be concise. 0.93. What is the ratio of the Employment to population ratio(%) of Czech Republic in 2000 to that in 2001?
Make the answer very short. 1.06. What is the ratio of the Employment to population ratio(%) in Malawi in 2000 to that in 2001?
Your response must be concise. 0.98. What is the ratio of the Employment to population ratio(%) of Namibia in 2000 to that in 2001?
Provide a short and direct response. 0.97. What is the ratio of the Employment to population ratio(%) in Czech Republic in 2000 to that in 2002?
Offer a terse response. 1.14. What is the ratio of the Employment to population ratio(%) of Malawi in 2000 to that in 2002?
Give a very brief answer. 0.95. What is the ratio of the Employment to population ratio(%) of Namibia in 2000 to that in 2002?
Provide a succinct answer. 0.91. What is the ratio of the Employment to population ratio(%) of Nicaragua in 2000 to that in 2002?
Your response must be concise. 0.99. What is the ratio of the Employment to population ratio(%) in Czech Republic in 2000 to that in 2003?
Your answer should be compact. 1.22. What is the ratio of the Employment to population ratio(%) of Malawi in 2000 to that in 2003?
Your response must be concise. 0.92. What is the ratio of the Employment to population ratio(%) of Namibia in 2000 to that in 2003?
Provide a succinct answer. 0.78. What is the ratio of the Employment to population ratio(%) of Nicaragua in 2000 to that in 2003?
Keep it short and to the point. 1.07. What is the ratio of the Employment to population ratio(%) of Czech Republic in 2000 to that in 2004?
Ensure brevity in your answer.  1.33. What is the ratio of the Employment to population ratio(%) in Malawi in 2000 to that in 2004?
Provide a succinct answer. 0.9. What is the ratio of the Employment to population ratio(%) of Namibia in 2000 to that in 2004?
Offer a terse response. 0.88. What is the ratio of the Employment to population ratio(%) in Nicaragua in 2000 to that in 2004?
Your answer should be compact. 1.01. What is the ratio of the Employment to population ratio(%) of Czech Republic in 2000 to that in 2005?
Your answer should be very brief. 1.47. What is the ratio of the Employment to population ratio(%) in Malawi in 2000 to that in 2005?
Provide a short and direct response. 0.88. What is the ratio of the Employment to population ratio(%) of Namibia in 2000 to that in 2005?
Your answer should be compact. 0.78. What is the ratio of the Employment to population ratio(%) in Nicaragua in 2000 to that in 2005?
Keep it short and to the point. 0.96. What is the ratio of the Employment to population ratio(%) in Czech Republic in 2001 to that in 2002?
Offer a terse response. 1.08. What is the ratio of the Employment to population ratio(%) in Malawi in 2001 to that in 2002?
Offer a very short reply. 0.97. What is the ratio of the Employment to population ratio(%) in Namibia in 2001 to that in 2002?
Offer a very short reply. 0.94. What is the ratio of the Employment to population ratio(%) of Nicaragua in 2001 to that in 2002?
Make the answer very short. 0.99. What is the ratio of the Employment to population ratio(%) of Czech Republic in 2001 to that in 2003?
Make the answer very short. 1.15. What is the ratio of the Employment to population ratio(%) of Malawi in 2001 to that in 2003?
Your answer should be very brief. 0.94. What is the ratio of the Employment to population ratio(%) in Namibia in 2001 to that in 2003?
Provide a succinct answer. 0.8. What is the ratio of the Employment to population ratio(%) of Nicaragua in 2001 to that in 2003?
Your answer should be compact. 1.07. What is the ratio of the Employment to population ratio(%) of Czech Republic in 2001 to that in 2004?
Your response must be concise. 1.26. What is the ratio of the Employment to population ratio(%) of Malawi in 2001 to that in 2004?
Your answer should be compact. 0.92. What is the ratio of the Employment to population ratio(%) of Namibia in 2001 to that in 2004?
Give a very brief answer. 0.91. What is the ratio of the Employment to population ratio(%) of Nicaragua in 2001 to that in 2004?
Provide a short and direct response. 1.02. What is the ratio of the Employment to population ratio(%) in Czech Republic in 2001 to that in 2005?
Your response must be concise. 1.39. What is the ratio of the Employment to population ratio(%) in Malawi in 2001 to that in 2005?
Your answer should be very brief. 0.9. What is the ratio of the Employment to population ratio(%) of Namibia in 2001 to that in 2005?
Offer a very short reply. 0.81. What is the ratio of the Employment to population ratio(%) in Nicaragua in 2001 to that in 2005?
Make the answer very short. 0.97. What is the ratio of the Employment to population ratio(%) of Czech Republic in 2002 to that in 2003?
Your response must be concise. 1.07. What is the ratio of the Employment to population ratio(%) in Malawi in 2002 to that in 2003?
Make the answer very short. 0.97. What is the ratio of the Employment to population ratio(%) in Namibia in 2002 to that in 2003?
Your answer should be very brief. 0.85. What is the ratio of the Employment to population ratio(%) in Nicaragua in 2002 to that in 2003?
Make the answer very short. 1.08. What is the ratio of the Employment to population ratio(%) of Czech Republic in 2002 to that in 2004?
Keep it short and to the point. 1.17. What is the ratio of the Employment to population ratio(%) of Malawi in 2002 to that in 2004?
Offer a very short reply. 0.95. What is the ratio of the Employment to population ratio(%) in Namibia in 2002 to that in 2004?
Ensure brevity in your answer.  0.97. What is the ratio of the Employment to population ratio(%) in Nicaragua in 2002 to that in 2004?
Your answer should be very brief. 1.02. What is the ratio of the Employment to population ratio(%) of Czech Republic in 2002 to that in 2005?
Provide a succinct answer. 1.29. What is the ratio of the Employment to population ratio(%) in Malawi in 2002 to that in 2005?
Provide a succinct answer. 0.93. What is the ratio of the Employment to population ratio(%) in Namibia in 2002 to that in 2005?
Ensure brevity in your answer.  0.86. What is the ratio of the Employment to population ratio(%) of Nicaragua in 2002 to that in 2005?
Offer a terse response. 0.97. What is the ratio of the Employment to population ratio(%) of Czech Republic in 2003 to that in 2004?
Your response must be concise. 1.1. What is the ratio of the Employment to population ratio(%) of Malawi in 2003 to that in 2004?
Keep it short and to the point. 0.98. What is the ratio of the Employment to population ratio(%) in Namibia in 2003 to that in 2004?
Provide a short and direct response. 1.14. What is the ratio of the Employment to population ratio(%) of Nicaragua in 2003 to that in 2004?
Give a very brief answer. 0.95. What is the ratio of the Employment to population ratio(%) of Czech Republic in 2003 to that in 2005?
Make the answer very short. 1.21. What is the ratio of the Employment to population ratio(%) in Malawi in 2003 to that in 2005?
Your answer should be compact. 0.96. What is the ratio of the Employment to population ratio(%) in Namibia in 2003 to that in 2005?
Keep it short and to the point. 1.01. What is the ratio of the Employment to population ratio(%) in Nicaragua in 2003 to that in 2005?
Give a very brief answer. 0.9. What is the ratio of the Employment to population ratio(%) in Czech Republic in 2004 to that in 2005?
Offer a very short reply. 1.1. What is the ratio of the Employment to population ratio(%) in Malawi in 2004 to that in 2005?
Make the answer very short. 0.98. What is the ratio of the Employment to population ratio(%) in Namibia in 2004 to that in 2005?
Give a very brief answer. 0.89. What is the ratio of the Employment to population ratio(%) in Nicaragua in 2004 to that in 2005?
Your response must be concise. 0.95. What is the difference between the highest and the second highest Employment to population ratio(%) in Czech Republic?
Give a very brief answer. 1.2. What is the difference between the highest and the lowest Employment to population ratio(%) of Czech Republic?
Offer a very short reply. 12.2. What is the difference between the highest and the lowest Employment to population ratio(%) in Malawi?
Your answer should be compact. 10.1. What is the difference between the highest and the lowest Employment to population ratio(%) in Namibia?
Ensure brevity in your answer.  4.4. What is the difference between the highest and the lowest Employment to population ratio(%) in Nicaragua?
Your answer should be very brief. 2.9. 